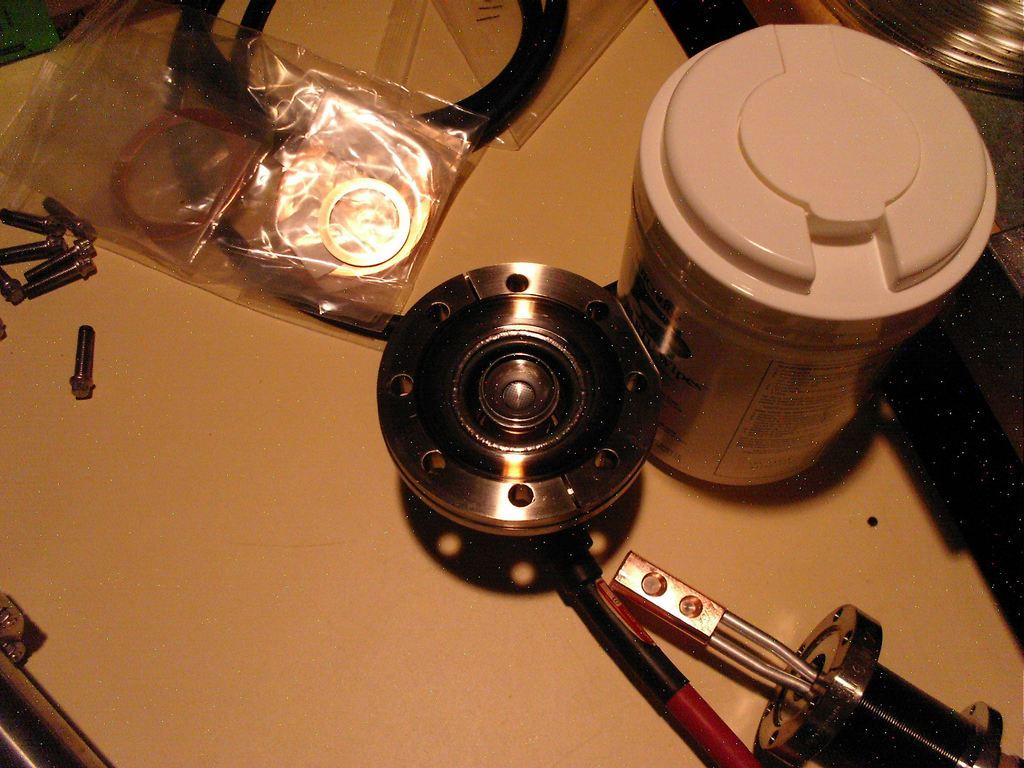What is the main piece of furniture in the image? There is a table in the image. What type of food items are on the table? There are nuts on the table. Is there any covering on the table? Yes, there is a cover on the table. What other items can be seen on the table? There is a tin and a wire on the table, as well as other objects. Can you tell me where the owl is hiding in the image? There is no owl present in the image. What type of cork is used to seal the tin on the table? There is no mention of a cork or a sealed tin in the image. 